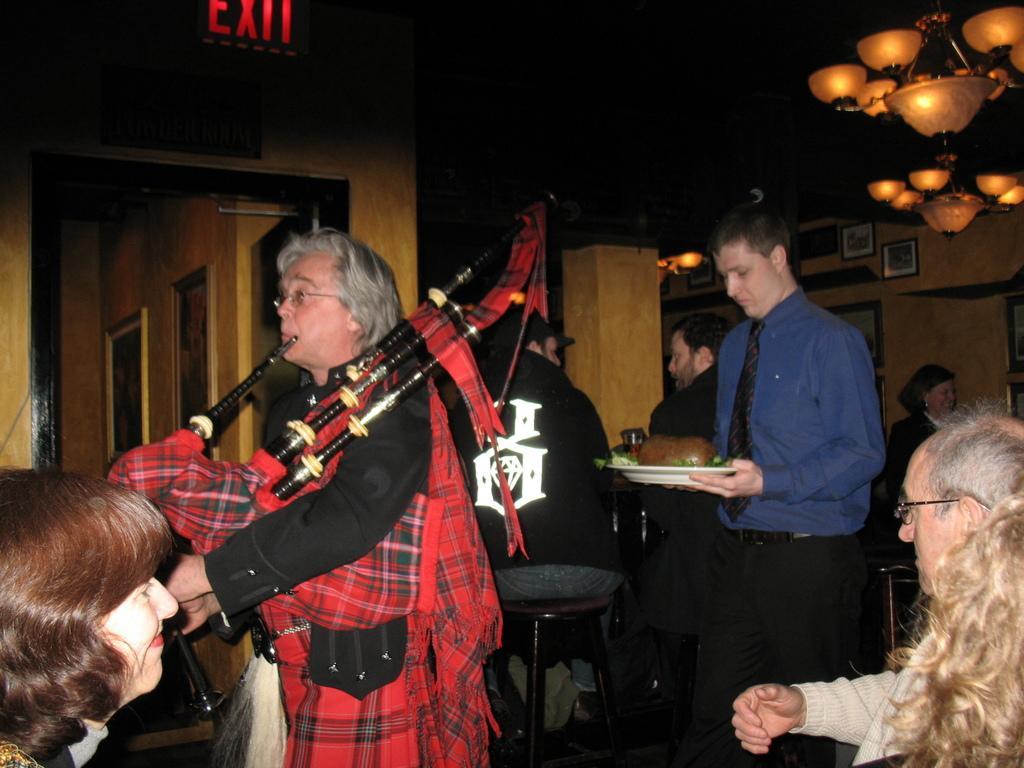How would you summarize this image in a sentence or two? In this image we can see there is an inside view of the building. There is one person playing musical instruments and few persons are sitting on the chair and one person is holding a plate and there is some food item. At the back there are photo frames attached to the wall. And at the top there is a chandelier. 